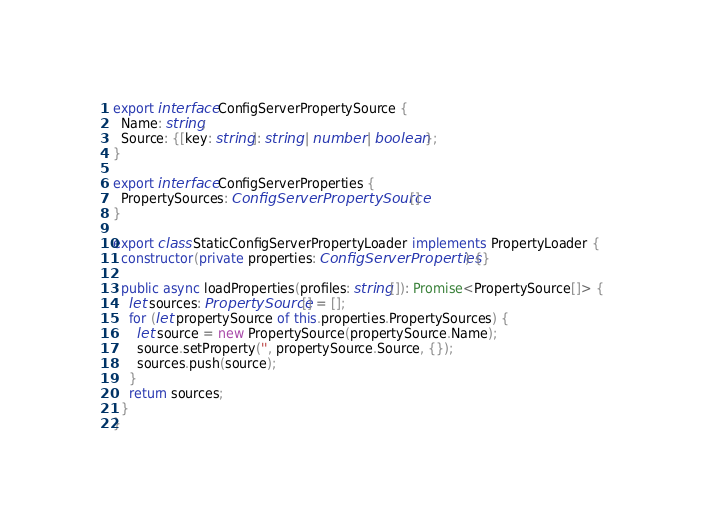Convert code to text. <code><loc_0><loc_0><loc_500><loc_500><_TypeScript_>export interface ConfigServerPropertySource {
  Name: string;
  Source: {[key: string]: string | number | boolean};
}

export interface ConfigServerProperties {
  PropertySources: ConfigServerPropertySource[]
}

export class StaticConfigServerPropertyLoader implements PropertyLoader {
  constructor(private properties: ConfigServerProperties) {}

  public async loadProperties(profiles: string[]): Promise<PropertySource[]> {
    let sources: PropertySource[] = [];
    for (let propertySource of this.properties.PropertySources) {
      let source = new PropertySource(propertySource.Name);
      source.setProperty('', propertySource.Source, {});
      sources.push(source);
    }
    return sources;
  }
}
</code> 